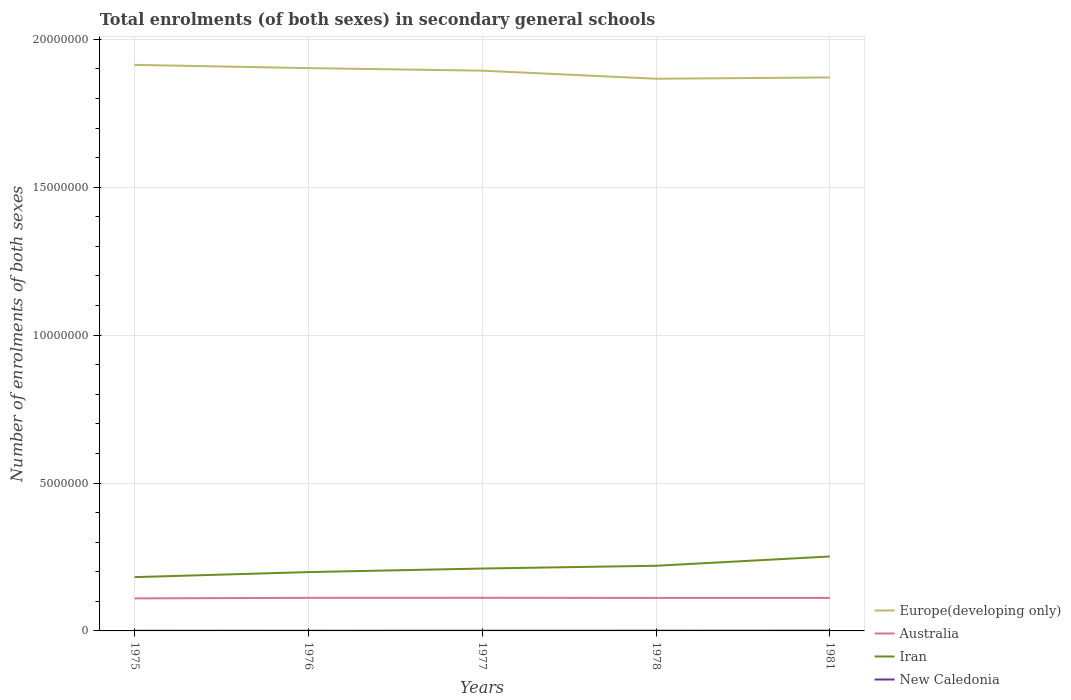Does the line corresponding to Australia intersect with the line corresponding to New Caledonia?
Provide a succinct answer. No. Is the number of lines equal to the number of legend labels?
Your answer should be very brief. Yes. Across all years, what is the maximum number of enrolments in secondary schools in Europe(developing only)?
Your answer should be very brief. 1.87e+07. In which year was the number of enrolments in secondary schools in Australia maximum?
Provide a short and direct response. 1975. What is the total number of enrolments in secondary schools in New Caledonia in the graph?
Provide a short and direct response. -862. What is the difference between the highest and the second highest number of enrolments in secondary schools in Iran?
Give a very brief answer. 6.98e+05. Is the number of enrolments in secondary schools in Australia strictly greater than the number of enrolments in secondary schools in Iran over the years?
Your response must be concise. Yes. Are the values on the major ticks of Y-axis written in scientific E-notation?
Give a very brief answer. No. Does the graph contain any zero values?
Keep it short and to the point. No. Does the graph contain grids?
Offer a very short reply. Yes. Where does the legend appear in the graph?
Keep it short and to the point. Bottom right. How are the legend labels stacked?
Provide a succinct answer. Vertical. What is the title of the graph?
Provide a succinct answer. Total enrolments (of both sexes) in secondary general schools. What is the label or title of the X-axis?
Provide a short and direct response. Years. What is the label or title of the Y-axis?
Make the answer very short. Number of enrolments of both sexes. What is the Number of enrolments of both sexes in Europe(developing only) in 1975?
Offer a terse response. 1.91e+07. What is the Number of enrolments of both sexes of Australia in 1975?
Your answer should be compact. 1.10e+06. What is the Number of enrolments of both sexes in Iran in 1975?
Make the answer very short. 1.82e+06. What is the Number of enrolments of both sexes in New Caledonia in 1975?
Offer a very short reply. 5604. What is the Number of enrolments of both sexes in Europe(developing only) in 1976?
Your answer should be very brief. 1.90e+07. What is the Number of enrolments of both sexes of Australia in 1976?
Your answer should be compact. 1.12e+06. What is the Number of enrolments of both sexes of Iran in 1976?
Give a very brief answer. 1.99e+06. What is the Number of enrolments of both sexes of New Caledonia in 1976?
Your answer should be very brief. 6406. What is the Number of enrolments of both sexes of Europe(developing only) in 1977?
Give a very brief answer. 1.89e+07. What is the Number of enrolments of both sexes of Australia in 1977?
Your answer should be very brief. 1.12e+06. What is the Number of enrolments of both sexes of Iran in 1977?
Your response must be concise. 2.11e+06. What is the Number of enrolments of both sexes of New Caledonia in 1977?
Offer a terse response. 7268. What is the Number of enrolments of both sexes in Europe(developing only) in 1978?
Provide a succinct answer. 1.87e+07. What is the Number of enrolments of both sexes in Australia in 1978?
Ensure brevity in your answer.  1.12e+06. What is the Number of enrolments of both sexes of Iran in 1978?
Your response must be concise. 2.20e+06. What is the Number of enrolments of both sexes in New Caledonia in 1978?
Offer a very short reply. 7948. What is the Number of enrolments of both sexes in Europe(developing only) in 1981?
Your answer should be very brief. 1.87e+07. What is the Number of enrolments of both sexes in Australia in 1981?
Offer a very short reply. 1.12e+06. What is the Number of enrolments of both sexes of Iran in 1981?
Offer a terse response. 2.52e+06. What is the Number of enrolments of both sexes of New Caledonia in 1981?
Ensure brevity in your answer.  1.01e+04. Across all years, what is the maximum Number of enrolments of both sexes in Europe(developing only)?
Offer a very short reply. 1.91e+07. Across all years, what is the maximum Number of enrolments of both sexes in Australia?
Offer a terse response. 1.12e+06. Across all years, what is the maximum Number of enrolments of both sexes in Iran?
Offer a very short reply. 2.52e+06. Across all years, what is the maximum Number of enrolments of both sexes in New Caledonia?
Your answer should be compact. 1.01e+04. Across all years, what is the minimum Number of enrolments of both sexes in Europe(developing only)?
Keep it short and to the point. 1.87e+07. Across all years, what is the minimum Number of enrolments of both sexes of Australia?
Make the answer very short. 1.10e+06. Across all years, what is the minimum Number of enrolments of both sexes of Iran?
Your response must be concise. 1.82e+06. Across all years, what is the minimum Number of enrolments of both sexes in New Caledonia?
Make the answer very short. 5604. What is the total Number of enrolments of both sexes in Europe(developing only) in the graph?
Provide a succinct answer. 9.45e+07. What is the total Number of enrolments of both sexes of Australia in the graph?
Your answer should be compact. 5.57e+06. What is the total Number of enrolments of both sexes of Iran in the graph?
Your response must be concise. 1.06e+07. What is the total Number of enrolments of both sexes of New Caledonia in the graph?
Provide a short and direct response. 3.74e+04. What is the difference between the Number of enrolments of both sexes of Europe(developing only) in 1975 and that in 1976?
Your response must be concise. 1.09e+05. What is the difference between the Number of enrolments of both sexes of Australia in 1975 and that in 1976?
Provide a short and direct response. -1.82e+04. What is the difference between the Number of enrolments of both sexes of Iran in 1975 and that in 1976?
Provide a succinct answer. -1.70e+05. What is the difference between the Number of enrolments of both sexes in New Caledonia in 1975 and that in 1976?
Offer a terse response. -802. What is the difference between the Number of enrolments of both sexes of Europe(developing only) in 1975 and that in 1977?
Keep it short and to the point. 1.96e+05. What is the difference between the Number of enrolments of both sexes in Australia in 1975 and that in 1977?
Provide a short and direct response. -2.02e+04. What is the difference between the Number of enrolments of both sexes in Iran in 1975 and that in 1977?
Give a very brief answer. -2.91e+05. What is the difference between the Number of enrolments of both sexes in New Caledonia in 1975 and that in 1977?
Your answer should be very brief. -1664. What is the difference between the Number of enrolments of both sexes in Europe(developing only) in 1975 and that in 1978?
Keep it short and to the point. 4.69e+05. What is the difference between the Number of enrolments of both sexes in Australia in 1975 and that in 1978?
Provide a succinct answer. -1.55e+04. What is the difference between the Number of enrolments of both sexes of Iran in 1975 and that in 1978?
Keep it short and to the point. -3.85e+05. What is the difference between the Number of enrolments of both sexes in New Caledonia in 1975 and that in 1978?
Provide a succinct answer. -2344. What is the difference between the Number of enrolments of both sexes of Europe(developing only) in 1975 and that in 1981?
Provide a succinct answer. 4.26e+05. What is the difference between the Number of enrolments of both sexes in Australia in 1975 and that in 1981?
Your answer should be very brief. -1.59e+04. What is the difference between the Number of enrolments of both sexes of Iran in 1975 and that in 1981?
Keep it short and to the point. -6.98e+05. What is the difference between the Number of enrolments of both sexes of New Caledonia in 1975 and that in 1981?
Provide a short and direct response. -4533. What is the difference between the Number of enrolments of both sexes in Europe(developing only) in 1976 and that in 1977?
Ensure brevity in your answer.  8.63e+04. What is the difference between the Number of enrolments of both sexes in Australia in 1976 and that in 1977?
Give a very brief answer. -2012. What is the difference between the Number of enrolments of both sexes of Iran in 1976 and that in 1977?
Give a very brief answer. -1.21e+05. What is the difference between the Number of enrolments of both sexes of New Caledonia in 1976 and that in 1977?
Ensure brevity in your answer.  -862. What is the difference between the Number of enrolments of both sexes of Europe(developing only) in 1976 and that in 1978?
Give a very brief answer. 3.59e+05. What is the difference between the Number of enrolments of both sexes of Australia in 1976 and that in 1978?
Ensure brevity in your answer.  2771. What is the difference between the Number of enrolments of both sexes of Iran in 1976 and that in 1978?
Give a very brief answer. -2.14e+05. What is the difference between the Number of enrolments of both sexes of New Caledonia in 1976 and that in 1978?
Your answer should be very brief. -1542. What is the difference between the Number of enrolments of both sexes of Europe(developing only) in 1976 and that in 1981?
Offer a terse response. 3.16e+05. What is the difference between the Number of enrolments of both sexes of Australia in 1976 and that in 1981?
Ensure brevity in your answer.  2367. What is the difference between the Number of enrolments of both sexes in Iran in 1976 and that in 1981?
Offer a very short reply. -5.28e+05. What is the difference between the Number of enrolments of both sexes in New Caledonia in 1976 and that in 1981?
Offer a very short reply. -3731. What is the difference between the Number of enrolments of both sexes in Europe(developing only) in 1977 and that in 1978?
Offer a very short reply. 2.73e+05. What is the difference between the Number of enrolments of both sexes in Australia in 1977 and that in 1978?
Keep it short and to the point. 4783. What is the difference between the Number of enrolments of both sexes of Iran in 1977 and that in 1978?
Keep it short and to the point. -9.35e+04. What is the difference between the Number of enrolments of both sexes in New Caledonia in 1977 and that in 1978?
Ensure brevity in your answer.  -680. What is the difference between the Number of enrolments of both sexes of Europe(developing only) in 1977 and that in 1981?
Provide a succinct answer. 2.30e+05. What is the difference between the Number of enrolments of both sexes of Australia in 1977 and that in 1981?
Keep it short and to the point. 4379. What is the difference between the Number of enrolments of both sexes in Iran in 1977 and that in 1981?
Offer a very short reply. -4.07e+05. What is the difference between the Number of enrolments of both sexes of New Caledonia in 1977 and that in 1981?
Offer a terse response. -2869. What is the difference between the Number of enrolments of both sexes in Europe(developing only) in 1978 and that in 1981?
Your response must be concise. -4.30e+04. What is the difference between the Number of enrolments of both sexes in Australia in 1978 and that in 1981?
Your answer should be compact. -404. What is the difference between the Number of enrolments of both sexes of Iran in 1978 and that in 1981?
Provide a short and direct response. -3.14e+05. What is the difference between the Number of enrolments of both sexes of New Caledonia in 1978 and that in 1981?
Give a very brief answer. -2189. What is the difference between the Number of enrolments of both sexes in Europe(developing only) in 1975 and the Number of enrolments of both sexes in Australia in 1976?
Ensure brevity in your answer.  1.80e+07. What is the difference between the Number of enrolments of both sexes of Europe(developing only) in 1975 and the Number of enrolments of both sexes of Iran in 1976?
Give a very brief answer. 1.71e+07. What is the difference between the Number of enrolments of both sexes of Europe(developing only) in 1975 and the Number of enrolments of both sexes of New Caledonia in 1976?
Provide a short and direct response. 1.91e+07. What is the difference between the Number of enrolments of both sexes of Australia in 1975 and the Number of enrolments of both sexes of Iran in 1976?
Provide a short and direct response. -8.89e+05. What is the difference between the Number of enrolments of both sexes in Australia in 1975 and the Number of enrolments of both sexes in New Caledonia in 1976?
Provide a short and direct response. 1.09e+06. What is the difference between the Number of enrolments of both sexes in Iran in 1975 and the Number of enrolments of both sexes in New Caledonia in 1976?
Provide a succinct answer. 1.81e+06. What is the difference between the Number of enrolments of both sexes of Europe(developing only) in 1975 and the Number of enrolments of both sexes of Australia in 1977?
Make the answer very short. 1.80e+07. What is the difference between the Number of enrolments of both sexes of Europe(developing only) in 1975 and the Number of enrolments of both sexes of Iran in 1977?
Offer a terse response. 1.70e+07. What is the difference between the Number of enrolments of both sexes of Europe(developing only) in 1975 and the Number of enrolments of both sexes of New Caledonia in 1977?
Give a very brief answer. 1.91e+07. What is the difference between the Number of enrolments of both sexes of Australia in 1975 and the Number of enrolments of both sexes of Iran in 1977?
Provide a short and direct response. -1.01e+06. What is the difference between the Number of enrolments of both sexes in Australia in 1975 and the Number of enrolments of both sexes in New Caledonia in 1977?
Ensure brevity in your answer.  1.09e+06. What is the difference between the Number of enrolments of both sexes in Iran in 1975 and the Number of enrolments of both sexes in New Caledonia in 1977?
Your response must be concise. 1.81e+06. What is the difference between the Number of enrolments of both sexes in Europe(developing only) in 1975 and the Number of enrolments of both sexes in Australia in 1978?
Ensure brevity in your answer.  1.80e+07. What is the difference between the Number of enrolments of both sexes in Europe(developing only) in 1975 and the Number of enrolments of both sexes in Iran in 1978?
Your answer should be compact. 1.69e+07. What is the difference between the Number of enrolments of both sexes of Europe(developing only) in 1975 and the Number of enrolments of both sexes of New Caledonia in 1978?
Your answer should be compact. 1.91e+07. What is the difference between the Number of enrolments of both sexes in Australia in 1975 and the Number of enrolments of both sexes in Iran in 1978?
Offer a very short reply. -1.10e+06. What is the difference between the Number of enrolments of both sexes in Australia in 1975 and the Number of enrolments of both sexes in New Caledonia in 1978?
Your response must be concise. 1.09e+06. What is the difference between the Number of enrolments of both sexes of Iran in 1975 and the Number of enrolments of both sexes of New Caledonia in 1978?
Your response must be concise. 1.81e+06. What is the difference between the Number of enrolments of both sexes in Europe(developing only) in 1975 and the Number of enrolments of both sexes in Australia in 1981?
Your answer should be very brief. 1.80e+07. What is the difference between the Number of enrolments of both sexes in Europe(developing only) in 1975 and the Number of enrolments of both sexes in Iran in 1981?
Offer a terse response. 1.66e+07. What is the difference between the Number of enrolments of both sexes in Europe(developing only) in 1975 and the Number of enrolments of both sexes in New Caledonia in 1981?
Make the answer very short. 1.91e+07. What is the difference between the Number of enrolments of both sexes in Australia in 1975 and the Number of enrolments of both sexes in Iran in 1981?
Ensure brevity in your answer.  -1.42e+06. What is the difference between the Number of enrolments of both sexes in Australia in 1975 and the Number of enrolments of both sexes in New Caledonia in 1981?
Your answer should be very brief. 1.09e+06. What is the difference between the Number of enrolments of both sexes of Iran in 1975 and the Number of enrolments of both sexes of New Caledonia in 1981?
Provide a succinct answer. 1.81e+06. What is the difference between the Number of enrolments of both sexes in Europe(developing only) in 1976 and the Number of enrolments of both sexes in Australia in 1977?
Keep it short and to the point. 1.79e+07. What is the difference between the Number of enrolments of both sexes in Europe(developing only) in 1976 and the Number of enrolments of both sexes in Iran in 1977?
Ensure brevity in your answer.  1.69e+07. What is the difference between the Number of enrolments of both sexes in Europe(developing only) in 1976 and the Number of enrolments of both sexes in New Caledonia in 1977?
Offer a terse response. 1.90e+07. What is the difference between the Number of enrolments of both sexes of Australia in 1976 and the Number of enrolments of both sexes of Iran in 1977?
Keep it short and to the point. -9.91e+05. What is the difference between the Number of enrolments of both sexes in Australia in 1976 and the Number of enrolments of both sexes in New Caledonia in 1977?
Keep it short and to the point. 1.11e+06. What is the difference between the Number of enrolments of both sexes in Iran in 1976 and the Number of enrolments of both sexes in New Caledonia in 1977?
Provide a succinct answer. 1.98e+06. What is the difference between the Number of enrolments of both sexes of Europe(developing only) in 1976 and the Number of enrolments of both sexes of Australia in 1978?
Provide a short and direct response. 1.79e+07. What is the difference between the Number of enrolments of both sexes in Europe(developing only) in 1976 and the Number of enrolments of both sexes in Iran in 1978?
Your response must be concise. 1.68e+07. What is the difference between the Number of enrolments of both sexes in Europe(developing only) in 1976 and the Number of enrolments of both sexes in New Caledonia in 1978?
Ensure brevity in your answer.  1.90e+07. What is the difference between the Number of enrolments of both sexes of Australia in 1976 and the Number of enrolments of both sexes of Iran in 1978?
Provide a succinct answer. -1.08e+06. What is the difference between the Number of enrolments of both sexes of Australia in 1976 and the Number of enrolments of both sexes of New Caledonia in 1978?
Provide a succinct answer. 1.11e+06. What is the difference between the Number of enrolments of both sexes of Iran in 1976 and the Number of enrolments of both sexes of New Caledonia in 1978?
Give a very brief answer. 1.98e+06. What is the difference between the Number of enrolments of both sexes of Europe(developing only) in 1976 and the Number of enrolments of both sexes of Australia in 1981?
Your answer should be very brief. 1.79e+07. What is the difference between the Number of enrolments of both sexes in Europe(developing only) in 1976 and the Number of enrolments of both sexes in Iran in 1981?
Ensure brevity in your answer.  1.65e+07. What is the difference between the Number of enrolments of both sexes of Europe(developing only) in 1976 and the Number of enrolments of both sexes of New Caledonia in 1981?
Offer a very short reply. 1.90e+07. What is the difference between the Number of enrolments of both sexes in Australia in 1976 and the Number of enrolments of both sexes in Iran in 1981?
Provide a succinct answer. -1.40e+06. What is the difference between the Number of enrolments of both sexes of Australia in 1976 and the Number of enrolments of both sexes of New Caledonia in 1981?
Provide a succinct answer. 1.11e+06. What is the difference between the Number of enrolments of both sexes of Iran in 1976 and the Number of enrolments of both sexes of New Caledonia in 1981?
Make the answer very short. 1.98e+06. What is the difference between the Number of enrolments of both sexes in Europe(developing only) in 1977 and the Number of enrolments of both sexes in Australia in 1978?
Give a very brief answer. 1.78e+07. What is the difference between the Number of enrolments of both sexes in Europe(developing only) in 1977 and the Number of enrolments of both sexes in Iran in 1978?
Your answer should be very brief. 1.67e+07. What is the difference between the Number of enrolments of both sexes of Europe(developing only) in 1977 and the Number of enrolments of both sexes of New Caledonia in 1978?
Your response must be concise. 1.89e+07. What is the difference between the Number of enrolments of both sexes in Australia in 1977 and the Number of enrolments of both sexes in Iran in 1978?
Offer a very short reply. -1.08e+06. What is the difference between the Number of enrolments of both sexes in Australia in 1977 and the Number of enrolments of both sexes in New Caledonia in 1978?
Offer a terse response. 1.11e+06. What is the difference between the Number of enrolments of both sexes of Iran in 1977 and the Number of enrolments of both sexes of New Caledonia in 1978?
Provide a succinct answer. 2.10e+06. What is the difference between the Number of enrolments of both sexes in Europe(developing only) in 1977 and the Number of enrolments of both sexes in Australia in 1981?
Ensure brevity in your answer.  1.78e+07. What is the difference between the Number of enrolments of both sexes of Europe(developing only) in 1977 and the Number of enrolments of both sexes of Iran in 1981?
Provide a succinct answer. 1.64e+07. What is the difference between the Number of enrolments of both sexes in Europe(developing only) in 1977 and the Number of enrolments of both sexes in New Caledonia in 1981?
Your response must be concise. 1.89e+07. What is the difference between the Number of enrolments of both sexes in Australia in 1977 and the Number of enrolments of both sexes in Iran in 1981?
Your response must be concise. -1.40e+06. What is the difference between the Number of enrolments of both sexes of Australia in 1977 and the Number of enrolments of both sexes of New Caledonia in 1981?
Give a very brief answer. 1.11e+06. What is the difference between the Number of enrolments of both sexes in Iran in 1977 and the Number of enrolments of both sexes in New Caledonia in 1981?
Offer a very short reply. 2.10e+06. What is the difference between the Number of enrolments of both sexes of Europe(developing only) in 1978 and the Number of enrolments of both sexes of Australia in 1981?
Give a very brief answer. 1.76e+07. What is the difference between the Number of enrolments of both sexes of Europe(developing only) in 1978 and the Number of enrolments of both sexes of Iran in 1981?
Give a very brief answer. 1.62e+07. What is the difference between the Number of enrolments of both sexes in Europe(developing only) in 1978 and the Number of enrolments of both sexes in New Caledonia in 1981?
Keep it short and to the point. 1.87e+07. What is the difference between the Number of enrolments of both sexes in Australia in 1978 and the Number of enrolments of both sexes in Iran in 1981?
Your answer should be compact. -1.40e+06. What is the difference between the Number of enrolments of both sexes in Australia in 1978 and the Number of enrolments of both sexes in New Caledonia in 1981?
Your answer should be very brief. 1.11e+06. What is the difference between the Number of enrolments of both sexes of Iran in 1978 and the Number of enrolments of both sexes of New Caledonia in 1981?
Make the answer very short. 2.19e+06. What is the average Number of enrolments of both sexes in Europe(developing only) per year?
Give a very brief answer. 1.89e+07. What is the average Number of enrolments of both sexes in Australia per year?
Your response must be concise. 1.11e+06. What is the average Number of enrolments of both sexes of Iran per year?
Offer a terse response. 2.13e+06. What is the average Number of enrolments of both sexes of New Caledonia per year?
Offer a very short reply. 7472.6. In the year 1975, what is the difference between the Number of enrolments of both sexes of Europe(developing only) and Number of enrolments of both sexes of Australia?
Ensure brevity in your answer.  1.80e+07. In the year 1975, what is the difference between the Number of enrolments of both sexes in Europe(developing only) and Number of enrolments of both sexes in Iran?
Your answer should be compact. 1.73e+07. In the year 1975, what is the difference between the Number of enrolments of both sexes in Europe(developing only) and Number of enrolments of both sexes in New Caledonia?
Make the answer very short. 1.91e+07. In the year 1975, what is the difference between the Number of enrolments of both sexes of Australia and Number of enrolments of both sexes of Iran?
Keep it short and to the point. -7.18e+05. In the year 1975, what is the difference between the Number of enrolments of both sexes of Australia and Number of enrolments of both sexes of New Caledonia?
Offer a very short reply. 1.09e+06. In the year 1975, what is the difference between the Number of enrolments of both sexes in Iran and Number of enrolments of both sexes in New Caledonia?
Ensure brevity in your answer.  1.81e+06. In the year 1976, what is the difference between the Number of enrolments of both sexes in Europe(developing only) and Number of enrolments of both sexes in Australia?
Provide a short and direct response. 1.79e+07. In the year 1976, what is the difference between the Number of enrolments of both sexes of Europe(developing only) and Number of enrolments of both sexes of Iran?
Offer a terse response. 1.70e+07. In the year 1976, what is the difference between the Number of enrolments of both sexes in Europe(developing only) and Number of enrolments of both sexes in New Caledonia?
Give a very brief answer. 1.90e+07. In the year 1976, what is the difference between the Number of enrolments of both sexes in Australia and Number of enrolments of both sexes in Iran?
Ensure brevity in your answer.  -8.71e+05. In the year 1976, what is the difference between the Number of enrolments of both sexes in Australia and Number of enrolments of both sexes in New Caledonia?
Your answer should be very brief. 1.11e+06. In the year 1976, what is the difference between the Number of enrolments of both sexes of Iran and Number of enrolments of both sexes of New Caledonia?
Give a very brief answer. 1.98e+06. In the year 1977, what is the difference between the Number of enrolments of both sexes of Europe(developing only) and Number of enrolments of both sexes of Australia?
Provide a short and direct response. 1.78e+07. In the year 1977, what is the difference between the Number of enrolments of both sexes in Europe(developing only) and Number of enrolments of both sexes in Iran?
Offer a very short reply. 1.68e+07. In the year 1977, what is the difference between the Number of enrolments of both sexes of Europe(developing only) and Number of enrolments of both sexes of New Caledonia?
Provide a short and direct response. 1.89e+07. In the year 1977, what is the difference between the Number of enrolments of both sexes of Australia and Number of enrolments of both sexes of Iran?
Make the answer very short. -9.89e+05. In the year 1977, what is the difference between the Number of enrolments of both sexes in Australia and Number of enrolments of both sexes in New Caledonia?
Give a very brief answer. 1.11e+06. In the year 1977, what is the difference between the Number of enrolments of both sexes of Iran and Number of enrolments of both sexes of New Caledonia?
Your answer should be compact. 2.10e+06. In the year 1978, what is the difference between the Number of enrolments of both sexes in Europe(developing only) and Number of enrolments of both sexes in Australia?
Offer a very short reply. 1.76e+07. In the year 1978, what is the difference between the Number of enrolments of both sexes in Europe(developing only) and Number of enrolments of both sexes in Iran?
Your answer should be compact. 1.65e+07. In the year 1978, what is the difference between the Number of enrolments of both sexes of Europe(developing only) and Number of enrolments of both sexes of New Caledonia?
Offer a very short reply. 1.87e+07. In the year 1978, what is the difference between the Number of enrolments of both sexes in Australia and Number of enrolments of both sexes in Iran?
Give a very brief answer. -1.09e+06. In the year 1978, what is the difference between the Number of enrolments of both sexes in Australia and Number of enrolments of both sexes in New Caledonia?
Your response must be concise. 1.11e+06. In the year 1978, what is the difference between the Number of enrolments of both sexes in Iran and Number of enrolments of both sexes in New Caledonia?
Ensure brevity in your answer.  2.19e+06. In the year 1981, what is the difference between the Number of enrolments of both sexes in Europe(developing only) and Number of enrolments of both sexes in Australia?
Offer a very short reply. 1.76e+07. In the year 1981, what is the difference between the Number of enrolments of both sexes in Europe(developing only) and Number of enrolments of both sexes in Iran?
Your answer should be compact. 1.62e+07. In the year 1981, what is the difference between the Number of enrolments of both sexes of Europe(developing only) and Number of enrolments of both sexes of New Caledonia?
Provide a short and direct response. 1.87e+07. In the year 1981, what is the difference between the Number of enrolments of both sexes of Australia and Number of enrolments of both sexes of Iran?
Offer a very short reply. -1.40e+06. In the year 1981, what is the difference between the Number of enrolments of both sexes in Australia and Number of enrolments of both sexes in New Caledonia?
Your response must be concise. 1.11e+06. In the year 1981, what is the difference between the Number of enrolments of both sexes in Iran and Number of enrolments of both sexes in New Caledonia?
Offer a very short reply. 2.51e+06. What is the ratio of the Number of enrolments of both sexes in Europe(developing only) in 1975 to that in 1976?
Your response must be concise. 1.01. What is the ratio of the Number of enrolments of both sexes of Australia in 1975 to that in 1976?
Keep it short and to the point. 0.98. What is the ratio of the Number of enrolments of both sexes of Iran in 1975 to that in 1976?
Provide a short and direct response. 0.91. What is the ratio of the Number of enrolments of both sexes of New Caledonia in 1975 to that in 1976?
Keep it short and to the point. 0.87. What is the ratio of the Number of enrolments of both sexes in Europe(developing only) in 1975 to that in 1977?
Give a very brief answer. 1.01. What is the ratio of the Number of enrolments of both sexes of Australia in 1975 to that in 1977?
Your response must be concise. 0.98. What is the ratio of the Number of enrolments of both sexes of Iran in 1975 to that in 1977?
Provide a succinct answer. 0.86. What is the ratio of the Number of enrolments of both sexes in New Caledonia in 1975 to that in 1977?
Provide a succinct answer. 0.77. What is the ratio of the Number of enrolments of both sexes of Europe(developing only) in 1975 to that in 1978?
Offer a very short reply. 1.03. What is the ratio of the Number of enrolments of both sexes of Australia in 1975 to that in 1978?
Keep it short and to the point. 0.99. What is the ratio of the Number of enrolments of both sexes of Iran in 1975 to that in 1978?
Give a very brief answer. 0.83. What is the ratio of the Number of enrolments of both sexes of New Caledonia in 1975 to that in 1978?
Give a very brief answer. 0.71. What is the ratio of the Number of enrolments of both sexes in Europe(developing only) in 1975 to that in 1981?
Offer a very short reply. 1.02. What is the ratio of the Number of enrolments of both sexes in Australia in 1975 to that in 1981?
Your answer should be compact. 0.99. What is the ratio of the Number of enrolments of both sexes of Iran in 1975 to that in 1981?
Provide a short and direct response. 0.72. What is the ratio of the Number of enrolments of both sexes in New Caledonia in 1975 to that in 1981?
Offer a terse response. 0.55. What is the ratio of the Number of enrolments of both sexes in Iran in 1976 to that in 1977?
Your answer should be compact. 0.94. What is the ratio of the Number of enrolments of both sexes in New Caledonia in 1976 to that in 1977?
Your answer should be compact. 0.88. What is the ratio of the Number of enrolments of both sexes in Europe(developing only) in 1976 to that in 1978?
Provide a succinct answer. 1.02. What is the ratio of the Number of enrolments of both sexes of Iran in 1976 to that in 1978?
Ensure brevity in your answer.  0.9. What is the ratio of the Number of enrolments of both sexes in New Caledonia in 1976 to that in 1978?
Your response must be concise. 0.81. What is the ratio of the Number of enrolments of both sexes of Europe(developing only) in 1976 to that in 1981?
Keep it short and to the point. 1.02. What is the ratio of the Number of enrolments of both sexes of Iran in 1976 to that in 1981?
Make the answer very short. 0.79. What is the ratio of the Number of enrolments of both sexes of New Caledonia in 1976 to that in 1981?
Offer a very short reply. 0.63. What is the ratio of the Number of enrolments of both sexes of Europe(developing only) in 1977 to that in 1978?
Offer a terse response. 1.01. What is the ratio of the Number of enrolments of both sexes of Iran in 1977 to that in 1978?
Provide a succinct answer. 0.96. What is the ratio of the Number of enrolments of both sexes in New Caledonia in 1977 to that in 1978?
Your response must be concise. 0.91. What is the ratio of the Number of enrolments of both sexes of Europe(developing only) in 1977 to that in 1981?
Make the answer very short. 1.01. What is the ratio of the Number of enrolments of both sexes of Iran in 1977 to that in 1981?
Keep it short and to the point. 0.84. What is the ratio of the Number of enrolments of both sexes in New Caledonia in 1977 to that in 1981?
Make the answer very short. 0.72. What is the ratio of the Number of enrolments of both sexes in Iran in 1978 to that in 1981?
Offer a very short reply. 0.88. What is the ratio of the Number of enrolments of both sexes of New Caledonia in 1978 to that in 1981?
Your answer should be compact. 0.78. What is the difference between the highest and the second highest Number of enrolments of both sexes of Europe(developing only)?
Your response must be concise. 1.09e+05. What is the difference between the highest and the second highest Number of enrolments of both sexes of Australia?
Your response must be concise. 2012. What is the difference between the highest and the second highest Number of enrolments of both sexes in Iran?
Make the answer very short. 3.14e+05. What is the difference between the highest and the second highest Number of enrolments of both sexes in New Caledonia?
Ensure brevity in your answer.  2189. What is the difference between the highest and the lowest Number of enrolments of both sexes of Europe(developing only)?
Provide a succinct answer. 4.69e+05. What is the difference between the highest and the lowest Number of enrolments of both sexes of Australia?
Give a very brief answer. 2.02e+04. What is the difference between the highest and the lowest Number of enrolments of both sexes in Iran?
Offer a very short reply. 6.98e+05. What is the difference between the highest and the lowest Number of enrolments of both sexes in New Caledonia?
Offer a terse response. 4533. 